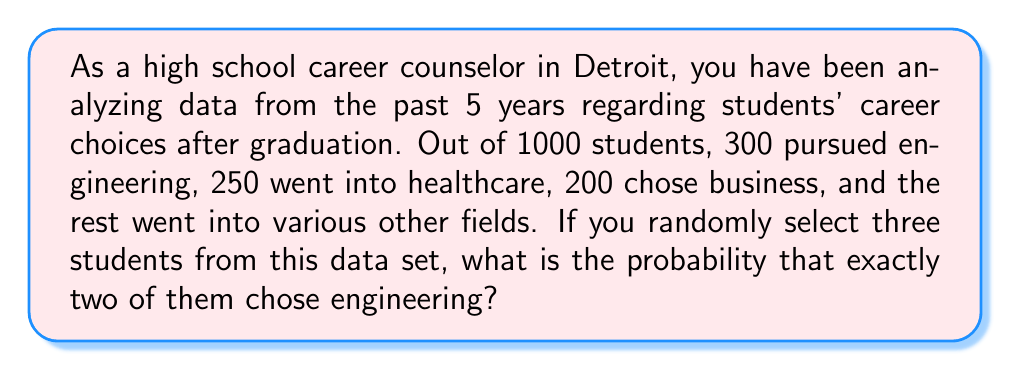Provide a solution to this math problem. To solve this problem, we'll use the concept of probability and combinations. Let's break it down step by step:

1) First, we need to calculate the probability of a student choosing engineering:
   $P(\text{engineering}) = \frac{300}{1000} = 0.3$

2) The probability of not choosing engineering is:
   $P(\text{not engineering}) = 1 - 0.3 = 0.7$

3) We want exactly two out of three students to have chosen engineering. This can be represented as a binomial probability problem.

4) The number of ways to choose 2 students out of 3 is given by the combination formula:
   $${3 \choose 2} = \frac{3!}{2!(3-2)!} = \frac{3 \cdot 2 \cdot 1}{(2 \cdot 1)(1)} = 3$$

5) Now we can use the binomial probability formula:
   $$P(X = k) = {n \choose k} p^k (1-p)^{n-k}$$
   Where:
   $n = 3$ (total number of students selected)
   $k = 2$ (number of successes, i.e., students who chose engineering)
   $p = 0.3$ (probability of choosing engineering)

6) Plugging in the values:
   $$P(X = 2) = {3 \choose 2} (0.3)^2 (0.7)^{3-2}$$
   $$= 3 \cdot (0.3)^2 \cdot (0.7)^1$$
   $$= 3 \cdot 0.09 \cdot 0.7$$
   $$= 0.189$$

Therefore, the probability of exactly two out of three randomly selected students having chosen engineering is 0.189 or 18.9%.
Answer: 0.189 or 18.9% 